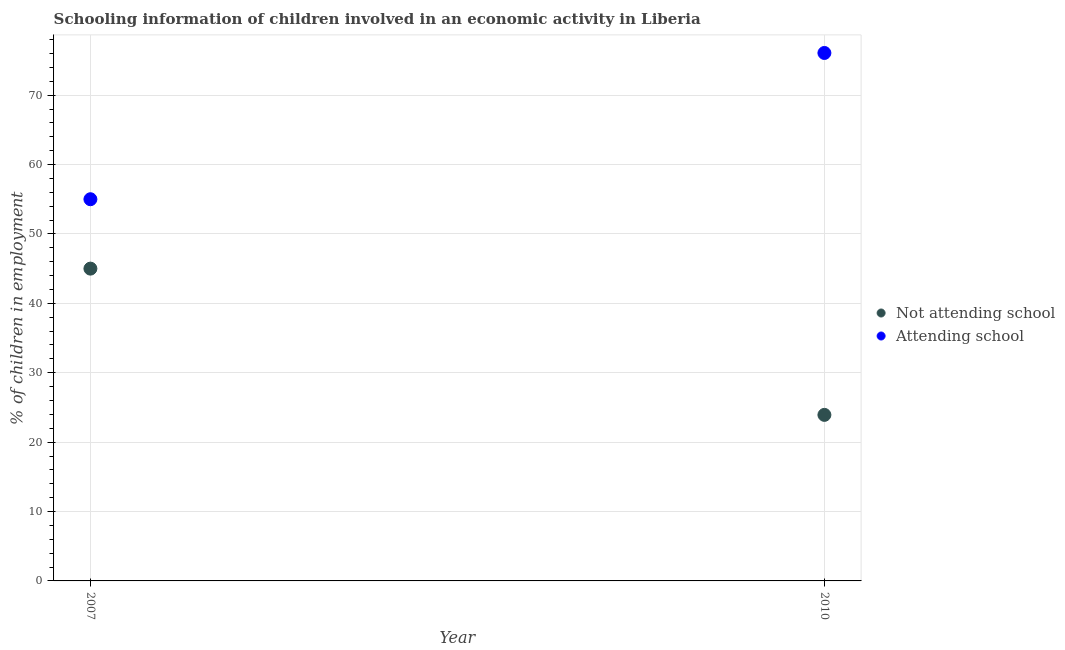How many different coloured dotlines are there?
Offer a very short reply. 2. Is the number of dotlines equal to the number of legend labels?
Provide a short and direct response. Yes. What is the percentage of employed children who are attending school in 2007?
Your answer should be very brief. 55. Across all years, what is the minimum percentage of employed children who are not attending school?
Your answer should be compact. 23.93. What is the total percentage of employed children who are attending school in the graph?
Your response must be concise. 131.07. What is the difference between the percentage of employed children who are not attending school in 2007 and that in 2010?
Make the answer very short. 21.07. What is the difference between the percentage of employed children who are not attending school in 2007 and the percentage of employed children who are attending school in 2010?
Give a very brief answer. -31.07. What is the average percentage of employed children who are attending school per year?
Offer a very short reply. 65.54. In the year 2010, what is the difference between the percentage of employed children who are attending school and percentage of employed children who are not attending school?
Provide a short and direct response. 52.15. What is the ratio of the percentage of employed children who are not attending school in 2007 to that in 2010?
Your response must be concise. 1.88. Is the percentage of employed children who are attending school strictly greater than the percentage of employed children who are not attending school over the years?
Keep it short and to the point. Yes. What is the difference between two consecutive major ticks on the Y-axis?
Provide a succinct answer. 10. Are the values on the major ticks of Y-axis written in scientific E-notation?
Ensure brevity in your answer.  No. Does the graph contain any zero values?
Your answer should be compact. No. Does the graph contain grids?
Make the answer very short. Yes. How are the legend labels stacked?
Your answer should be very brief. Vertical. What is the title of the graph?
Your answer should be compact. Schooling information of children involved in an economic activity in Liberia. Does "Education" appear as one of the legend labels in the graph?
Your response must be concise. No. What is the label or title of the Y-axis?
Your response must be concise. % of children in employment. What is the % of children in employment of Attending school in 2007?
Your answer should be compact. 55. What is the % of children in employment in Not attending school in 2010?
Provide a succinct answer. 23.93. What is the % of children in employment in Attending school in 2010?
Your response must be concise. 76.07. Across all years, what is the maximum % of children in employment in Not attending school?
Provide a succinct answer. 45. Across all years, what is the maximum % of children in employment in Attending school?
Provide a short and direct response. 76.07. Across all years, what is the minimum % of children in employment of Not attending school?
Keep it short and to the point. 23.93. Across all years, what is the minimum % of children in employment of Attending school?
Offer a terse response. 55. What is the total % of children in employment of Not attending school in the graph?
Your response must be concise. 68.93. What is the total % of children in employment in Attending school in the graph?
Offer a terse response. 131.07. What is the difference between the % of children in employment in Not attending school in 2007 and that in 2010?
Ensure brevity in your answer.  21.07. What is the difference between the % of children in employment of Attending school in 2007 and that in 2010?
Offer a terse response. -21.07. What is the difference between the % of children in employment in Not attending school in 2007 and the % of children in employment in Attending school in 2010?
Offer a terse response. -31.07. What is the average % of children in employment of Not attending school per year?
Offer a very short reply. 34.46. What is the average % of children in employment in Attending school per year?
Provide a succinct answer. 65.54. In the year 2010, what is the difference between the % of children in employment of Not attending school and % of children in employment of Attending school?
Ensure brevity in your answer.  -52.15. What is the ratio of the % of children in employment in Not attending school in 2007 to that in 2010?
Your answer should be very brief. 1.88. What is the ratio of the % of children in employment in Attending school in 2007 to that in 2010?
Offer a very short reply. 0.72. What is the difference between the highest and the second highest % of children in employment in Not attending school?
Offer a very short reply. 21.07. What is the difference between the highest and the second highest % of children in employment of Attending school?
Make the answer very short. 21.07. What is the difference between the highest and the lowest % of children in employment in Not attending school?
Offer a very short reply. 21.07. What is the difference between the highest and the lowest % of children in employment of Attending school?
Your response must be concise. 21.07. 